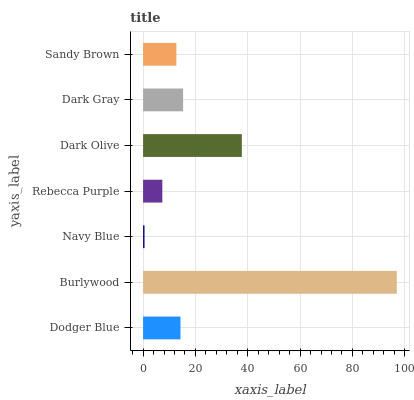Is Navy Blue the minimum?
Answer yes or no. Yes. Is Burlywood the maximum?
Answer yes or no. Yes. Is Burlywood the minimum?
Answer yes or no. No. Is Navy Blue the maximum?
Answer yes or no. No. Is Burlywood greater than Navy Blue?
Answer yes or no. Yes. Is Navy Blue less than Burlywood?
Answer yes or no. Yes. Is Navy Blue greater than Burlywood?
Answer yes or no. No. Is Burlywood less than Navy Blue?
Answer yes or no. No. Is Dodger Blue the high median?
Answer yes or no. Yes. Is Dodger Blue the low median?
Answer yes or no. Yes. Is Dark Gray the high median?
Answer yes or no. No. Is Dark Olive the low median?
Answer yes or no. No. 